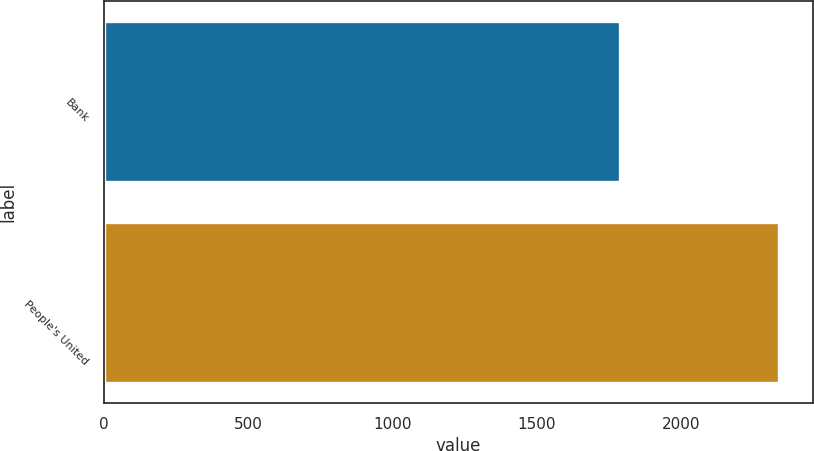Convert chart. <chart><loc_0><loc_0><loc_500><loc_500><bar_chart><fcel>Bank<fcel>People's United<nl><fcel>1789.8<fcel>2341<nl></chart> 